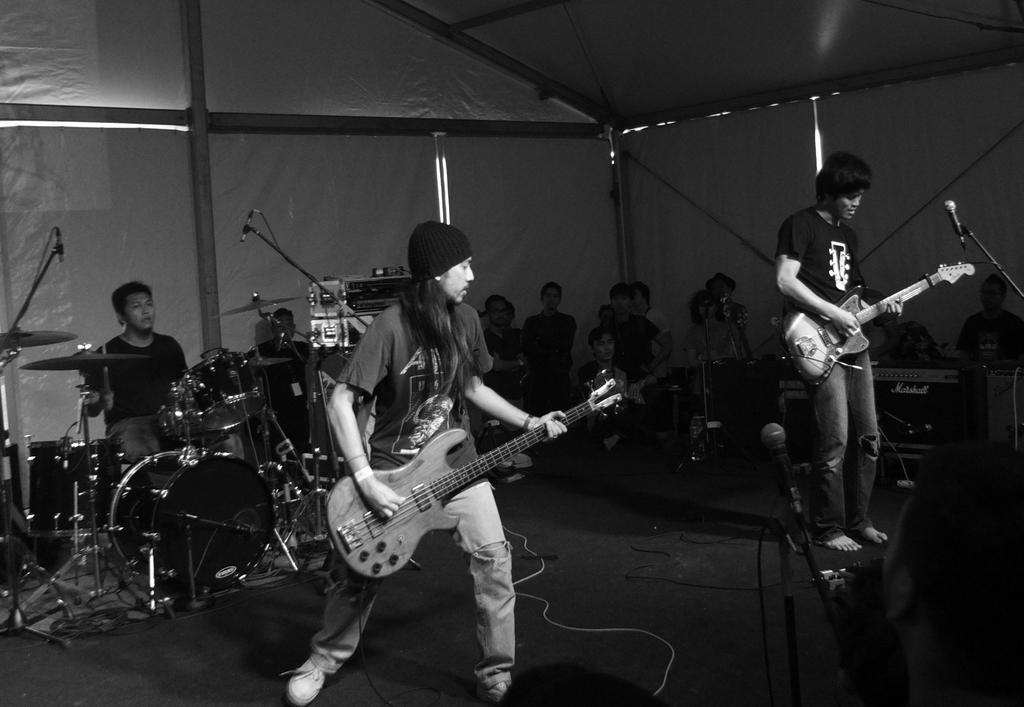Could you give a brief overview of what you see in this image? This is a black and white picture. Here we can see two persons are playing guitar. On the background we can see some persons. Here we can see a man who is playing drums. These are some musical instruments and this is floor. 